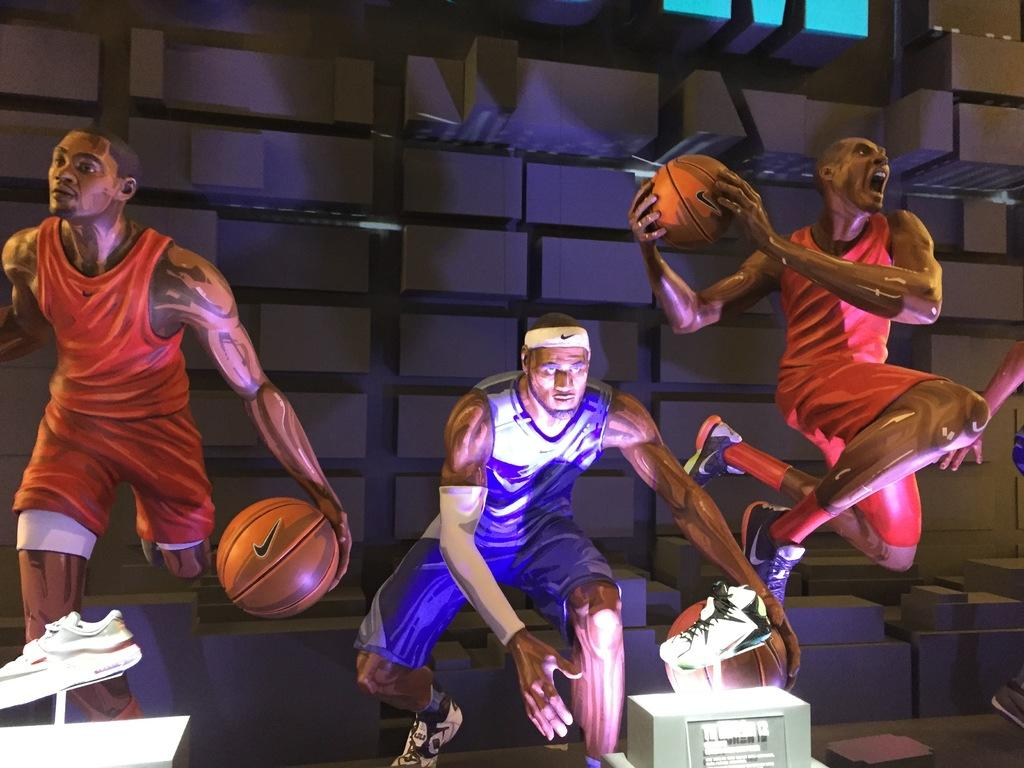What type of objects can be seen in the image? There are statues, shoes, and balls in the image. What is the background of the image? There is a wall in the image. What type of creature is holding the flag in the image? There is no creature or flag present in the image. 